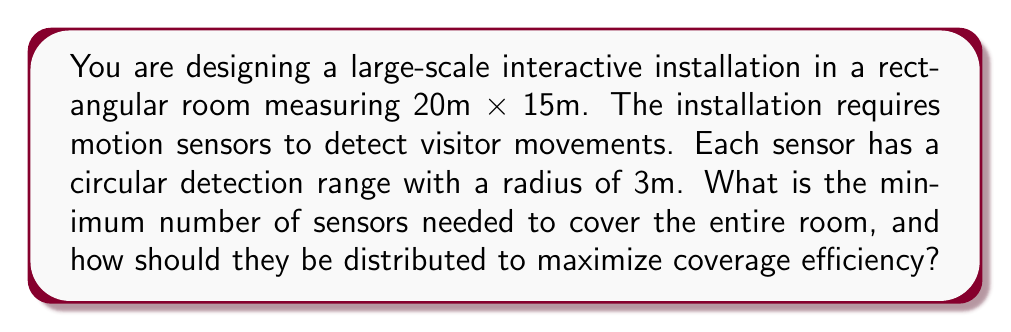What is the answer to this math problem? To solve this problem, we need to follow these steps:

1. Calculate the total area of the room:
   $$A_{room} = 20m \times 15m = 300m^2$$

2. Calculate the area covered by each sensor:
   $$A_{sensor} = \pi r^2 = \pi (3m)^2 \approx 28.27m^2$$

3. To find the theoretical minimum number of sensors, divide the room area by the sensor area:
   $$N_{min} = \frac{A_{room}}{A_{sensor}} = \frac{300m^2}{28.27m^2} \approx 10.61$$
   
   Round up to the nearest whole number: 11 sensors.

4. However, this doesn't account for optimal distribution. To maximize coverage efficiency, we need to arrange the sensors in a grid pattern that minimizes overlap while covering the entire room.

5. The most efficient packing of circles is a hexagonal grid, where each circle is surrounded by six others. In this arrangement, the centers of the circles form equilateral triangles.

6. The distance between sensor centers in this optimal arrangement is:
   $$d = r\sqrt{3} = 3m \times \sqrt{3} \approx 5.2m$$

7. To cover the room, we need:
   - Rows: $\lceil 15m / (3m \times \sqrt{3}/2) \rceil = \lceil 3.46 \rceil = 4$
   - Columns: $\lceil 20m / (3m \times \sqrt{3}) \rceil = \lceil 3.85 \rceil = 4$

8. The total number of sensors in this grid is:
   $$N_{total} = 4 \times 4 = 16$$

9. To distribute the sensors:
   - Space them 5.2m apart in both directions
   - Offset every other row by 2.6m (half the distance between sensors)

This arrangement ensures complete coverage of the room with minimal overlap, optimizing the use of each sensor's detection range.
Answer: The minimum number of sensors needed is 16, arranged in a 4x4 hexagonal grid with sensors spaced 5.2m apart and every other row offset by 2.6m. 